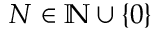<formula> <loc_0><loc_0><loc_500><loc_500>N \in \mathbb { N } \cup \{ 0 \}</formula> 